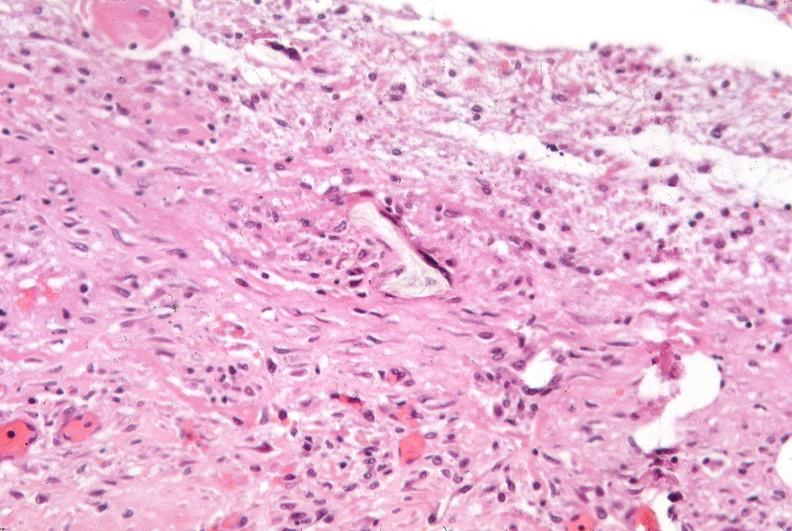what is present?
Answer the question using a single word or phrase. Respiratory 